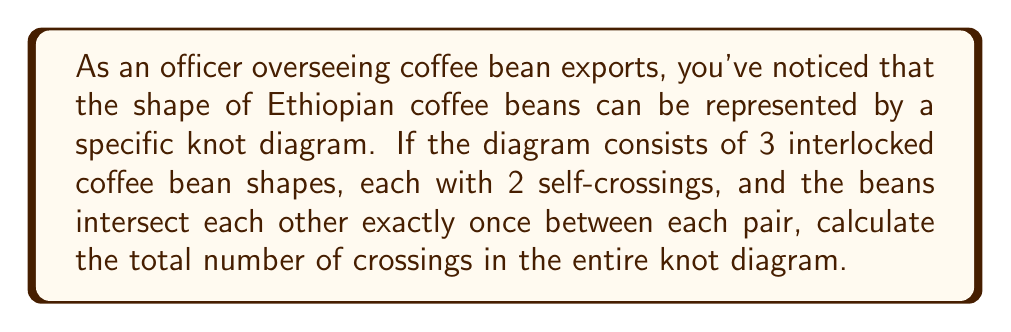Show me your answer to this math problem. Let's approach this step-by-step:

1. First, we need to count the self-crossings of each coffee bean shape:
   - There are 3 coffee bean shapes
   - Each shape has 2 self-crossings
   - Total self-crossings: $3 \times 2 = 6$

2. Next, we need to count the intersections between pairs of coffee beans:
   - There are $\binom{3}{2} = 3$ pairs of coffee beans (1-2, 1-3, 2-3)
   - Each pair intersects exactly once
   - Total intersections between pairs: $3 \times 1 = 3$

3. The total number of crossings is the sum of self-crossings and intersections:
   $$ \text{Total crossings} = \text{Self-crossings} + \text{Intersections} $$
   $$ \text{Total crossings} = 6 + 3 = 9 $$

Therefore, the knot diagram representing the interlocked coffee bean shapes has 9 crossings in total.
Answer: 9 crossings 